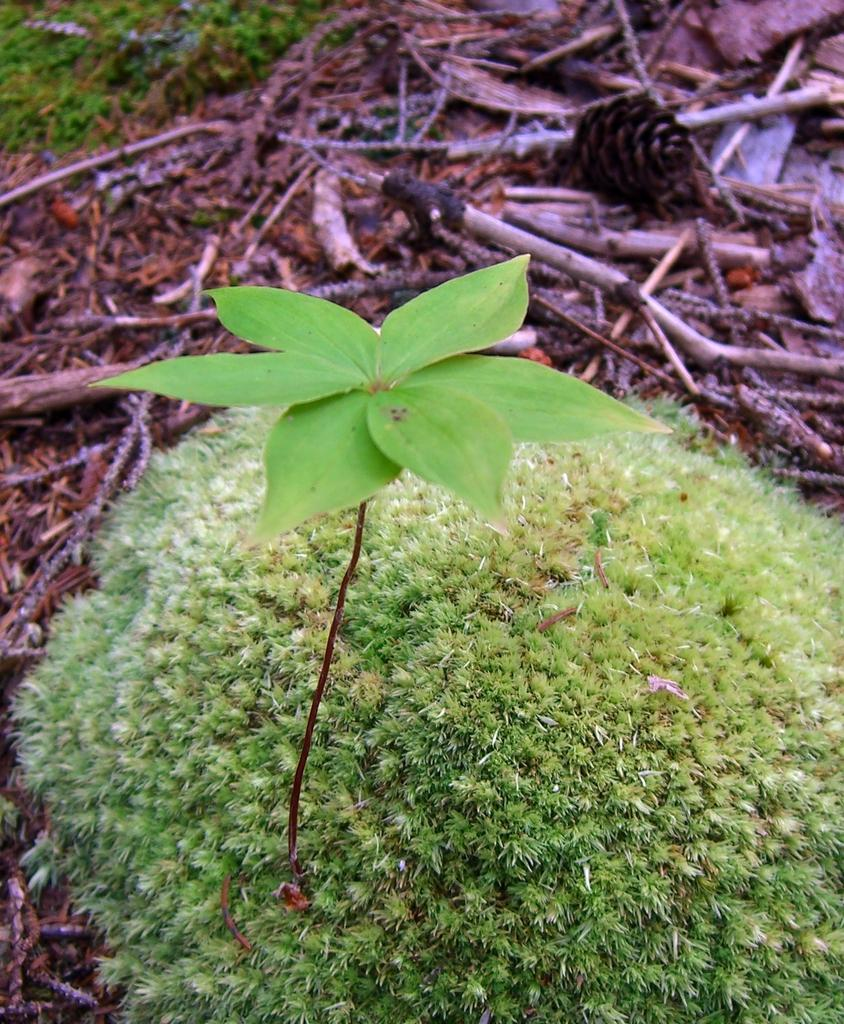What type of plant can be seen in the image? There is a green plant in the image. What material are the logs made of in the image? The logs in the image are made of wood. What can be found on the ground in the image? There are brown leaves on the ground in the image. What type of power source is visible in the image? There is no power source visible in the image; it features a green plant, wooden logs, and brown leaves. Can you tell me how much knowledge is contained within the wooden logs in the image? There is no knowledge contained within the wooden logs in the image; they are simply logs made of wood. 